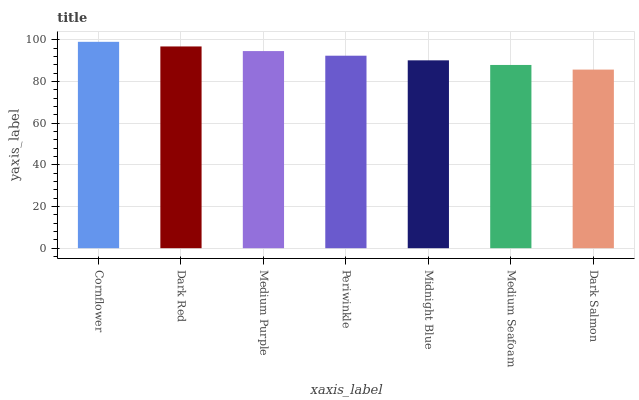Is Dark Red the minimum?
Answer yes or no. No. Is Dark Red the maximum?
Answer yes or no. No. Is Cornflower greater than Dark Red?
Answer yes or no. Yes. Is Dark Red less than Cornflower?
Answer yes or no. Yes. Is Dark Red greater than Cornflower?
Answer yes or no. No. Is Cornflower less than Dark Red?
Answer yes or no. No. Is Periwinkle the high median?
Answer yes or no. Yes. Is Periwinkle the low median?
Answer yes or no. Yes. Is Dark Salmon the high median?
Answer yes or no. No. Is Dark Salmon the low median?
Answer yes or no. No. 